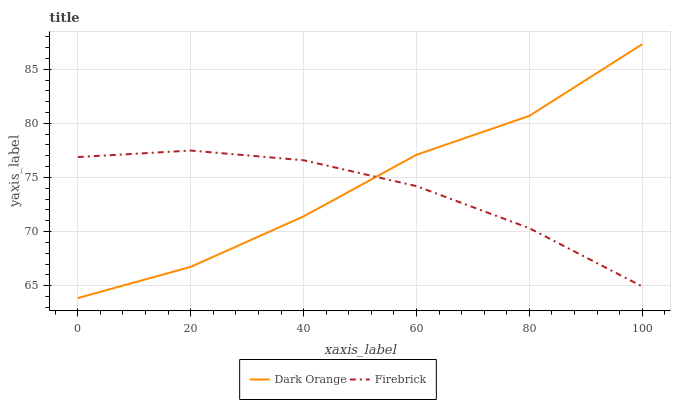Does Firebrick have the minimum area under the curve?
Answer yes or no. Yes. Does Dark Orange have the maximum area under the curve?
Answer yes or no. Yes. Does Firebrick have the maximum area under the curve?
Answer yes or no. No. Is Firebrick the smoothest?
Answer yes or no. Yes. Is Dark Orange the roughest?
Answer yes or no. Yes. Is Firebrick the roughest?
Answer yes or no. No. Does Firebrick have the lowest value?
Answer yes or no. No. Does Dark Orange have the highest value?
Answer yes or no. Yes. Does Firebrick have the highest value?
Answer yes or no. No. Does Firebrick intersect Dark Orange?
Answer yes or no. Yes. Is Firebrick less than Dark Orange?
Answer yes or no. No. Is Firebrick greater than Dark Orange?
Answer yes or no. No. 